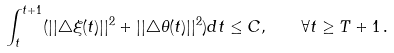Convert formula to latex. <formula><loc_0><loc_0><loc_500><loc_500>\int _ { t } ^ { t + 1 } ( | | \triangle \xi ( t ) | | ^ { 2 } + | | \triangle \theta ( t ) | | ^ { 2 } ) d t \leq C , \quad \forall t \geq T + 1 \, .</formula> 